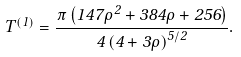<formula> <loc_0><loc_0><loc_500><loc_500>T ^ { ( 1 ) } = \frac { \pi \left ( 1 4 7 \rho ^ { 2 } + 3 8 4 \rho + 2 5 6 \right ) } { 4 \left ( 4 + 3 \rho \right ) ^ { 5 / 2 } } .</formula> 